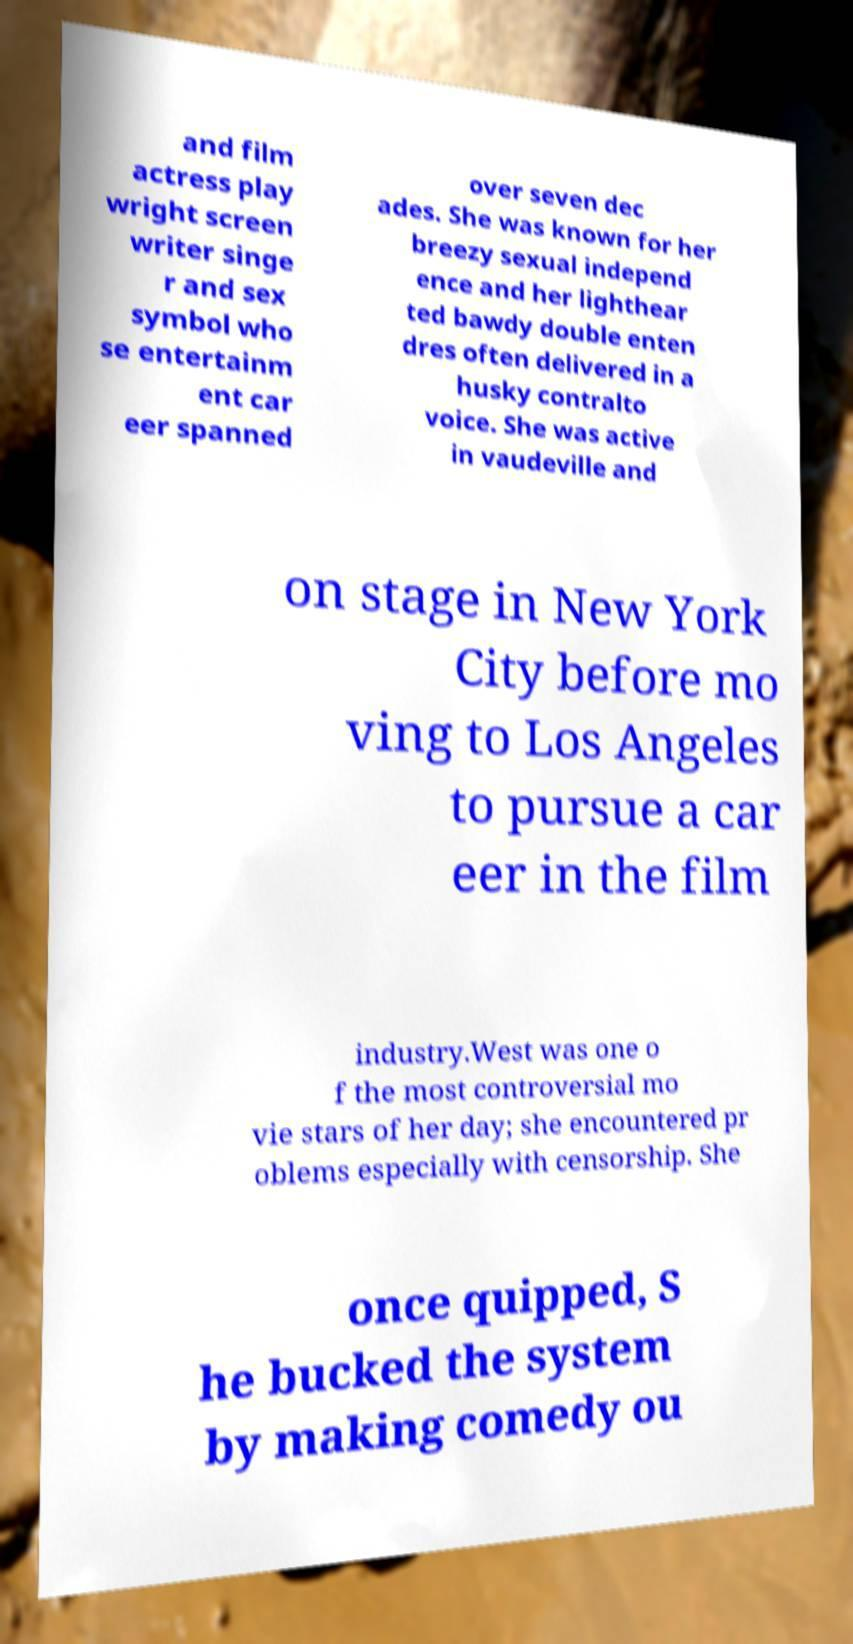For documentation purposes, I need the text within this image transcribed. Could you provide that? and film actress play wright screen writer singe r and sex symbol who se entertainm ent car eer spanned over seven dec ades. She was known for her breezy sexual independ ence and her lighthear ted bawdy double enten dres often delivered in a husky contralto voice. She was active in vaudeville and on stage in New York City before mo ving to Los Angeles to pursue a car eer in the film industry.West was one o f the most controversial mo vie stars of her day; she encountered pr oblems especially with censorship. She once quipped, S he bucked the system by making comedy ou 